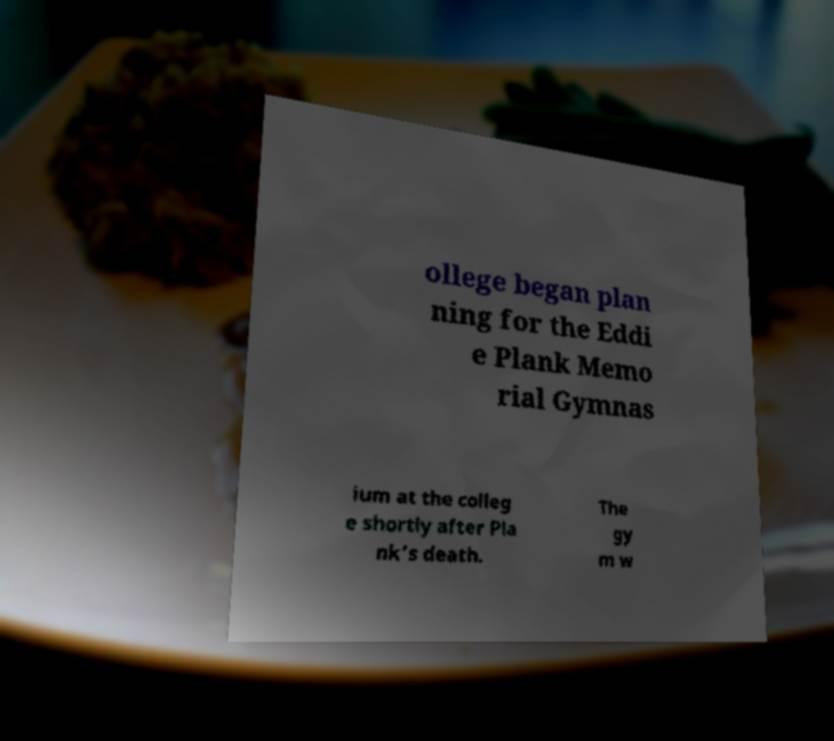Please identify and transcribe the text found in this image. ollege began plan ning for the Eddi e Plank Memo rial Gymnas ium at the colleg e shortly after Pla nk's death. The gy m w 